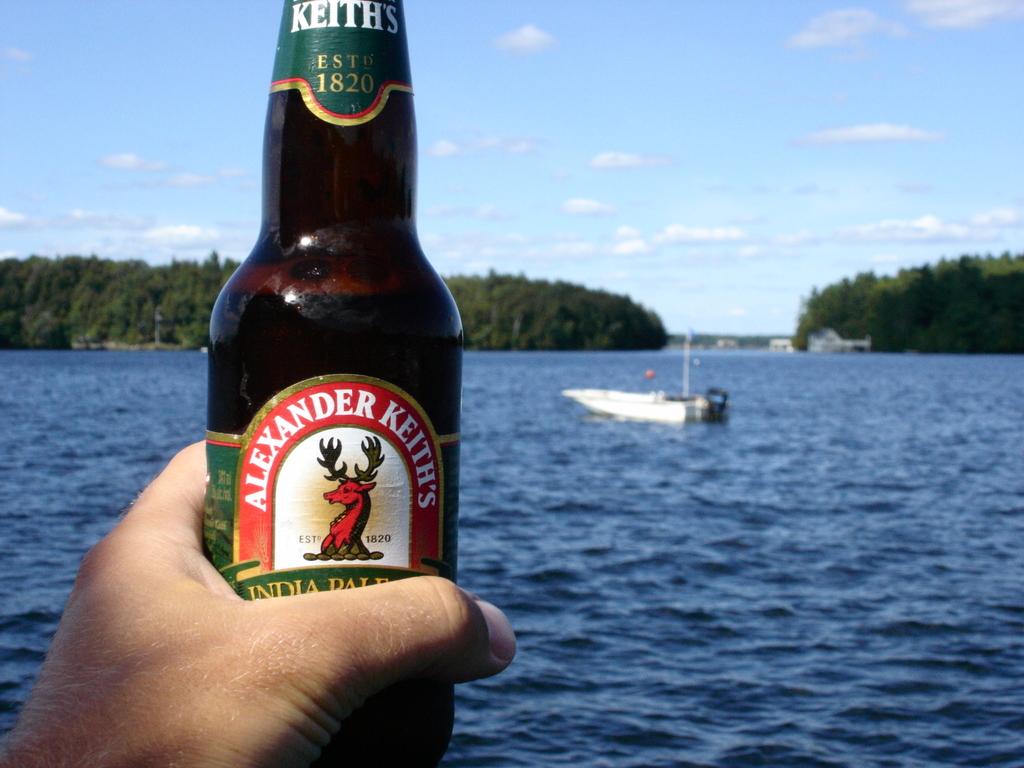What is the brand of the beer?
Make the answer very short. Alexander keith's. What year was this beer brand established?
Offer a terse response. 1820. 